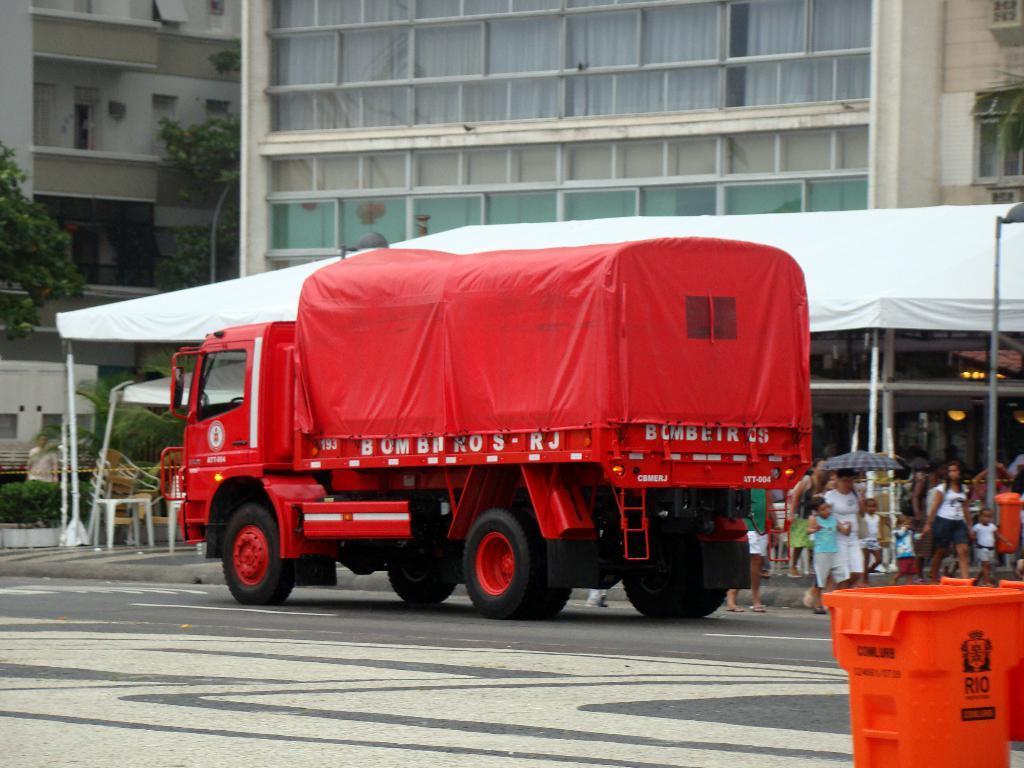How would you summarize this image in a sentence or two? In this image there is a red colour lorry in the middle. In the background there is a tent under which there are so many people walking on the road. In the background there is a building. On the right side bottom there is a dustbin. There are chairs and tables under the tent. 